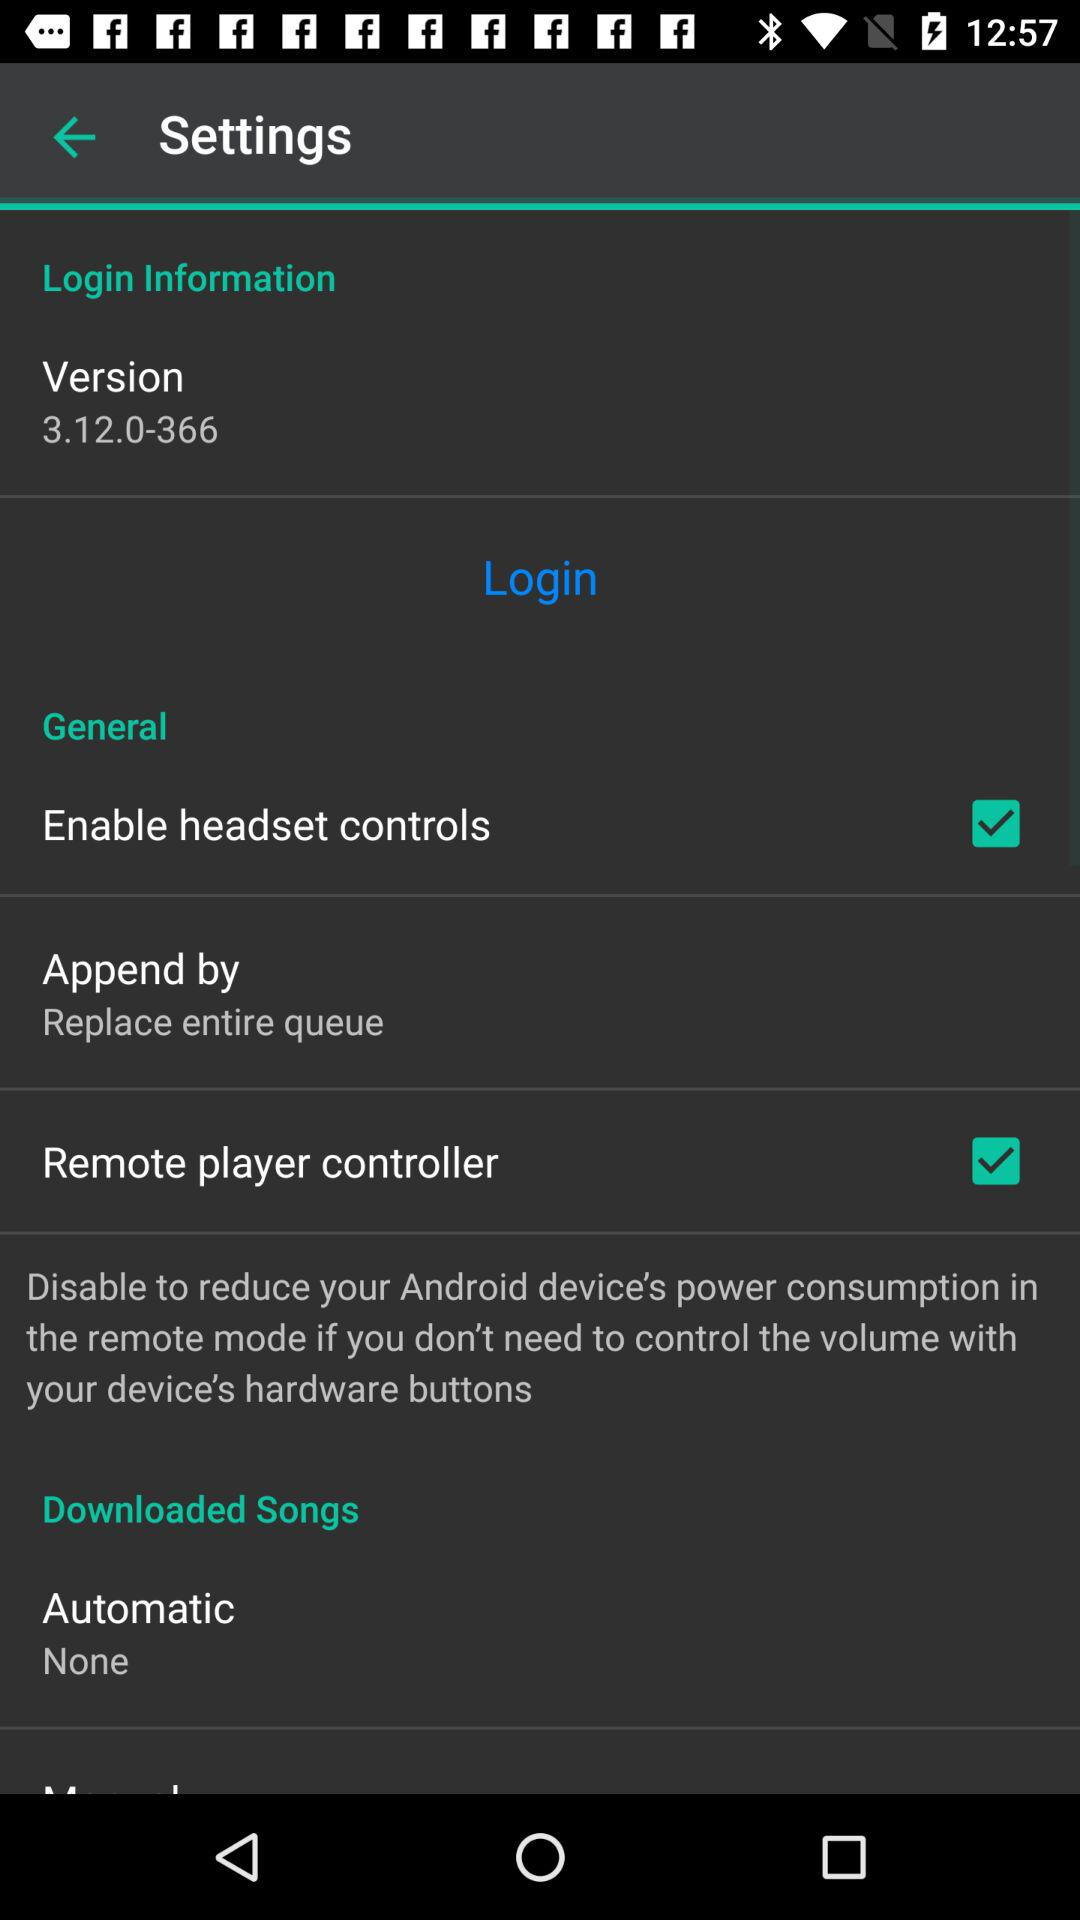What is the status of "Remote player controller"? The status is "on". 